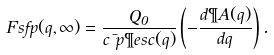<formula> <loc_0><loc_0><loc_500><loc_500>\ F s f p ( q , \infty ) = \frac { Q _ { 0 } } { c \mu p \P e s c ( q ) } \left ( - \frac { d \P A ( q ) } { d q } \right ) .</formula> 